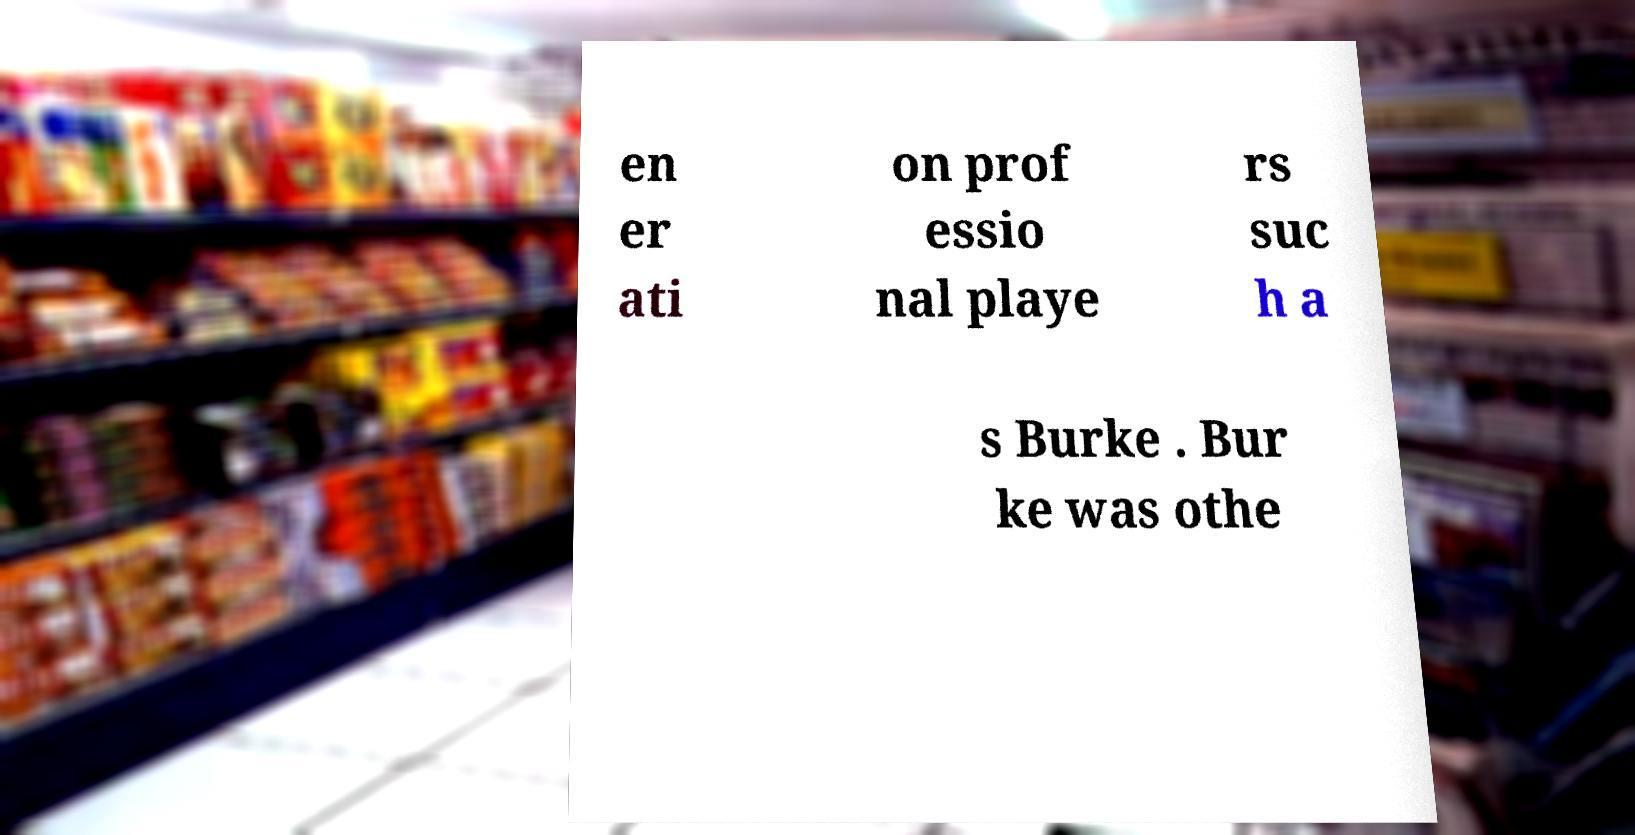What messages or text are displayed in this image? I need them in a readable, typed format. en er ati on prof essio nal playe rs suc h a s Burke . Bur ke was othe 